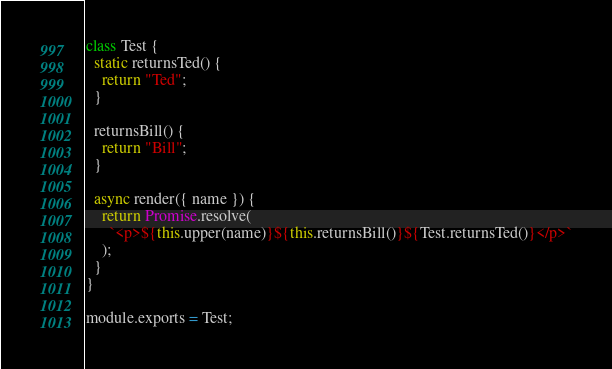Convert code to text. <code><loc_0><loc_0><loc_500><loc_500><_JavaScript_>class Test {
  static returnsTed() {
    return "Ted";
  }

  returnsBill() {
    return "Bill";
  }

  async render({ name }) {
    return Promise.resolve(
      `<p>${this.upper(name)}${this.returnsBill()}${Test.returnsTed()}</p>`
    );
  }
}

module.exports = Test;
</code> 